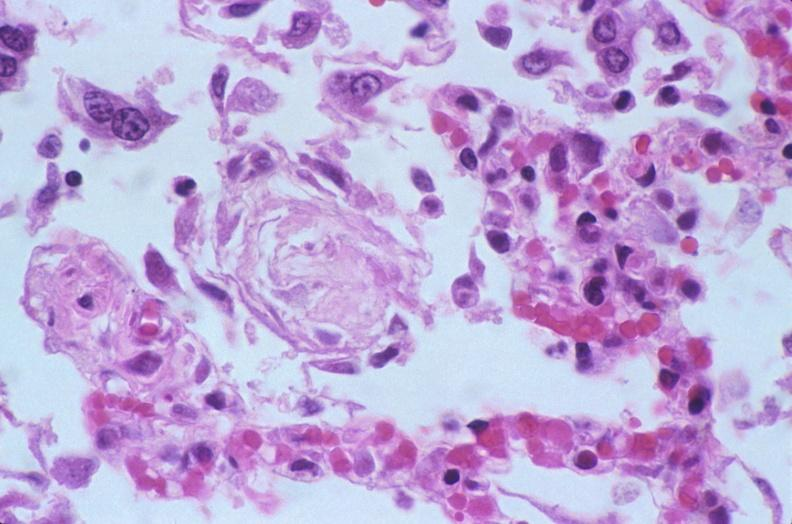s respiratory present?
Answer the question using a single word or phrase. Yes 